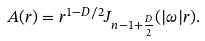Convert formula to latex. <formula><loc_0><loc_0><loc_500><loc_500>A ( r ) = r ^ { 1 - D / 2 } J _ { n - 1 + { \frac { D } { 2 } } } ( | \omega | r ) .</formula> 